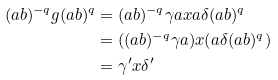<formula> <loc_0><loc_0><loc_500><loc_500>( a b ) ^ { - q } g ( a b ) ^ { q } & = ( a b ) ^ { - q } \gamma a x a \delta ( a b ) ^ { q } \\ & = ( ( a b ) ^ { - q } \gamma a ) x ( a \delta ( a b ) ^ { q } ) \\ & = \gamma ^ { \prime } x \delta ^ { \prime }</formula> 